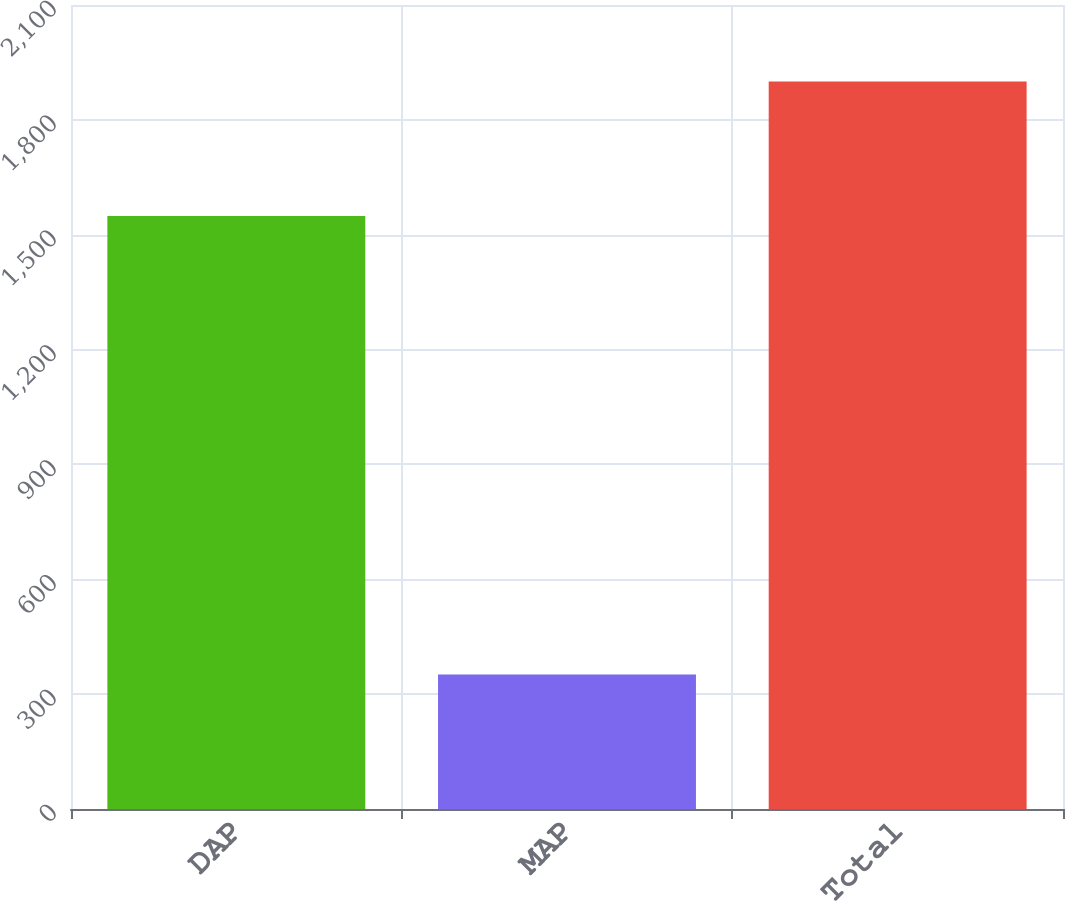<chart> <loc_0><loc_0><loc_500><loc_500><bar_chart><fcel>DAP<fcel>MAP<fcel>Total<nl><fcel>1549<fcel>351<fcel>1900<nl></chart> 